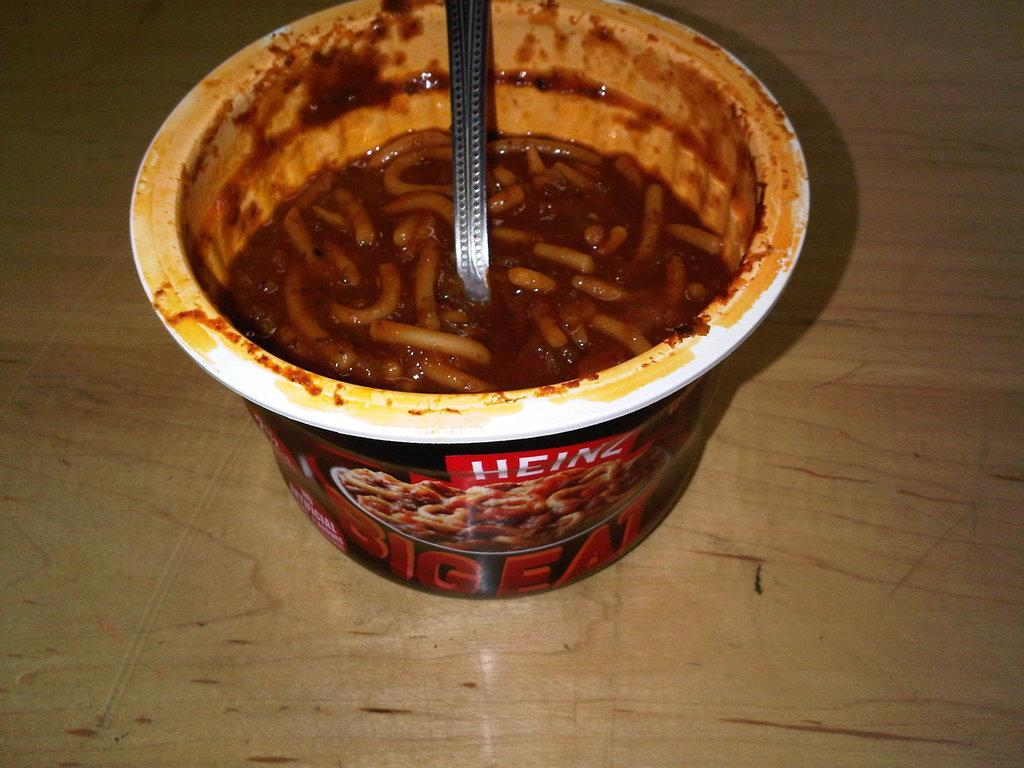What utensil is visible in the image? There is a spoon in the image. What type of food is in the cup that is visible in the image? There is a cup of noodles in the image. Where is the cup of noodles located? The cup of noodles is on a table. How far does the light from the spoon reach in the image? There is no indication of light emanating from the spoon in the image. What type of rest can be seen in the image? There is no rest or resting activity depicted in the image. 